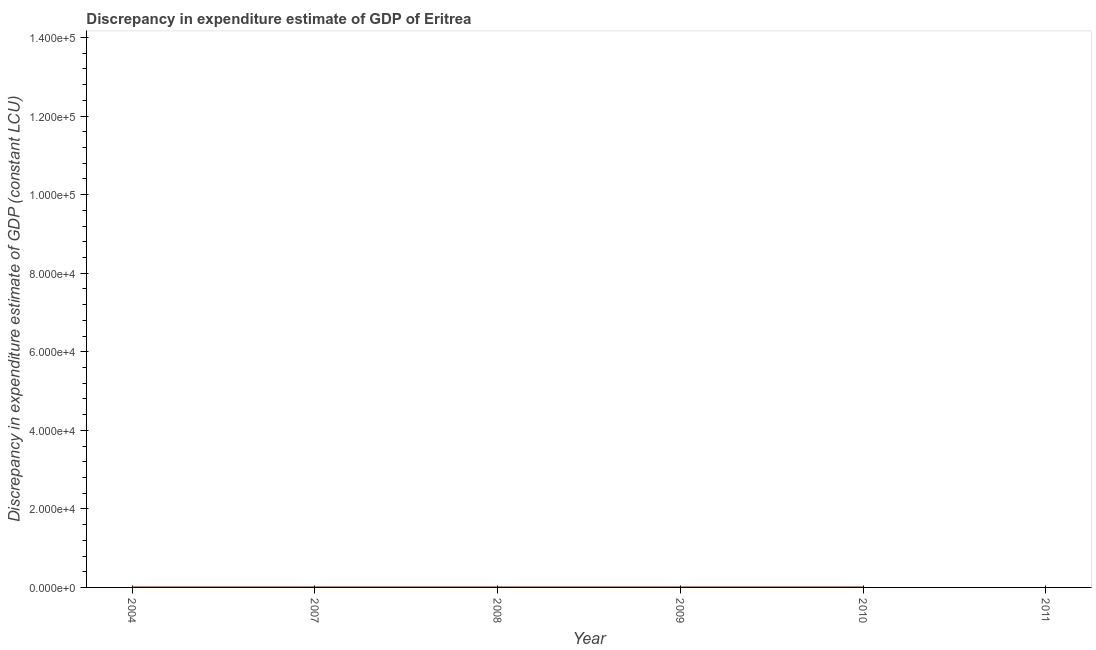What is the discrepancy in expenditure estimate of gdp in 2011?
Keep it short and to the point. 0. Across all years, what is the maximum discrepancy in expenditure estimate of gdp?
Offer a terse response. 0. Across all years, what is the minimum discrepancy in expenditure estimate of gdp?
Make the answer very short. 0. What is the sum of the discrepancy in expenditure estimate of gdp?
Keep it short and to the point. 0. What is the difference between the discrepancy in expenditure estimate of gdp in 2004 and 2010?
Give a very brief answer. -0. What is the average discrepancy in expenditure estimate of gdp per year?
Give a very brief answer. 0. Is the difference between the discrepancy in expenditure estimate of gdp in 2004 and 2008 greater than the difference between any two years?
Provide a succinct answer. No. What is the difference between the highest and the second highest discrepancy in expenditure estimate of gdp?
Give a very brief answer. 0. Is the sum of the discrepancy in expenditure estimate of gdp in 2004 and 2009 greater than the maximum discrepancy in expenditure estimate of gdp across all years?
Make the answer very short. No. What is the difference between two consecutive major ticks on the Y-axis?
Keep it short and to the point. 2.00e+04. What is the title of the graph?
Keep it short and to the point. Discrepancy in expenditure estimate of GDP of Eritrea. What is the label or title of the Y-axis?
Ensure brevity in your answer.  Discrepancy in expenditure estimate of GDP (constant LCU). What is the Discrepancy in expenditure estimate of GDP (constant LCU) of 2008?
Your response must be concise. 0. What is the Discrepancy in expenditure estimate of GDP (constant LCU) in 2009?
Make the answer very short. 0. What is the Discrepancy in expenditure estimate of GDP (constant LCU) in 2010?
Provide a short and direct response. 0. What is the difference between the Discrepancy in expenditure estimate of GDP (constant LCU) in 2004 and 2010?
Ensure brevity in your answer.  -0. What is the difference between the Discrepancy in expenditure estimate of GDP (constant LCU) in 2007 and 2010?
Your response must be concise. -0. What is the difference between the Discrepancy in expenditure estimate of GDP (constant LCU) in 2008 and 2010?
Your answer should be compact. -0. What is the difference between the Discrepancy in expenditure estimate of GDP (constant LCU) in 2009 and 2010?
Make the answer very short. -0. What is the ratio of the Discrepancy in expenditure estimate of GDP (constant LCU) in 2004 to that in 2008?
Make the answer very short. 1. What is the ratio of the Discrepancy in expenditure estimate of GDP (constant LCU) in 2004 to that in 2009?
Offer a terse response. 1. What is the ratio of the Discrepancy in expenditure estimate of GDP (constant LCU) in 2007 to that in 2010?
Your answer should be compact. 0.5. What is the ratio of the Discrepancy in expenditure estimate of GDP (constant LCU) in 2008 to that in 2010?
Offer a very short reply. 0.5. What is the ratio of the Discrepancy in expenditure estimate of GDP (constant LCU) in 2009 to that in 2010?
Offer a terse response. 0.5. 